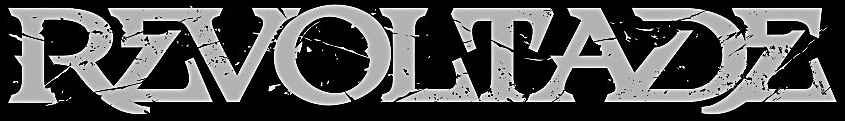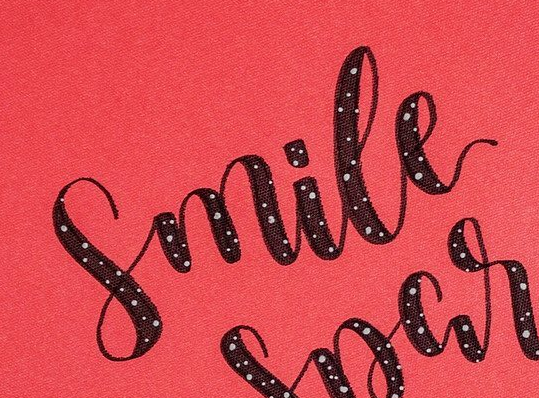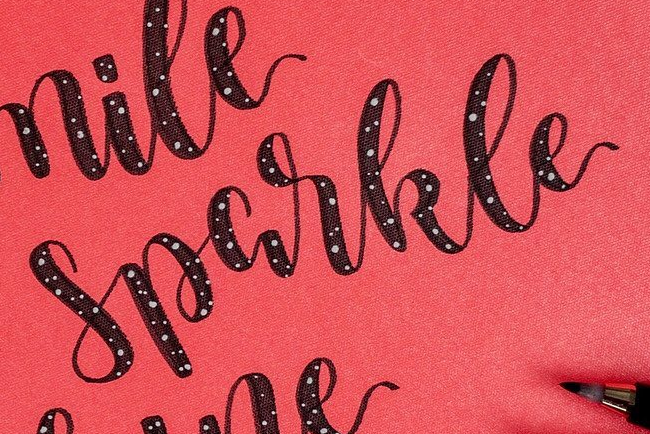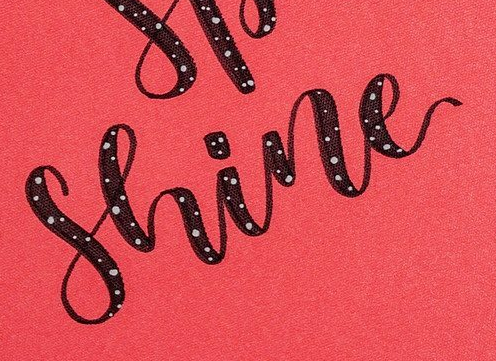What text appears in these images from left to right, separated by a semicolon? REVOLTADE; Smile; Sparkle; Shine 